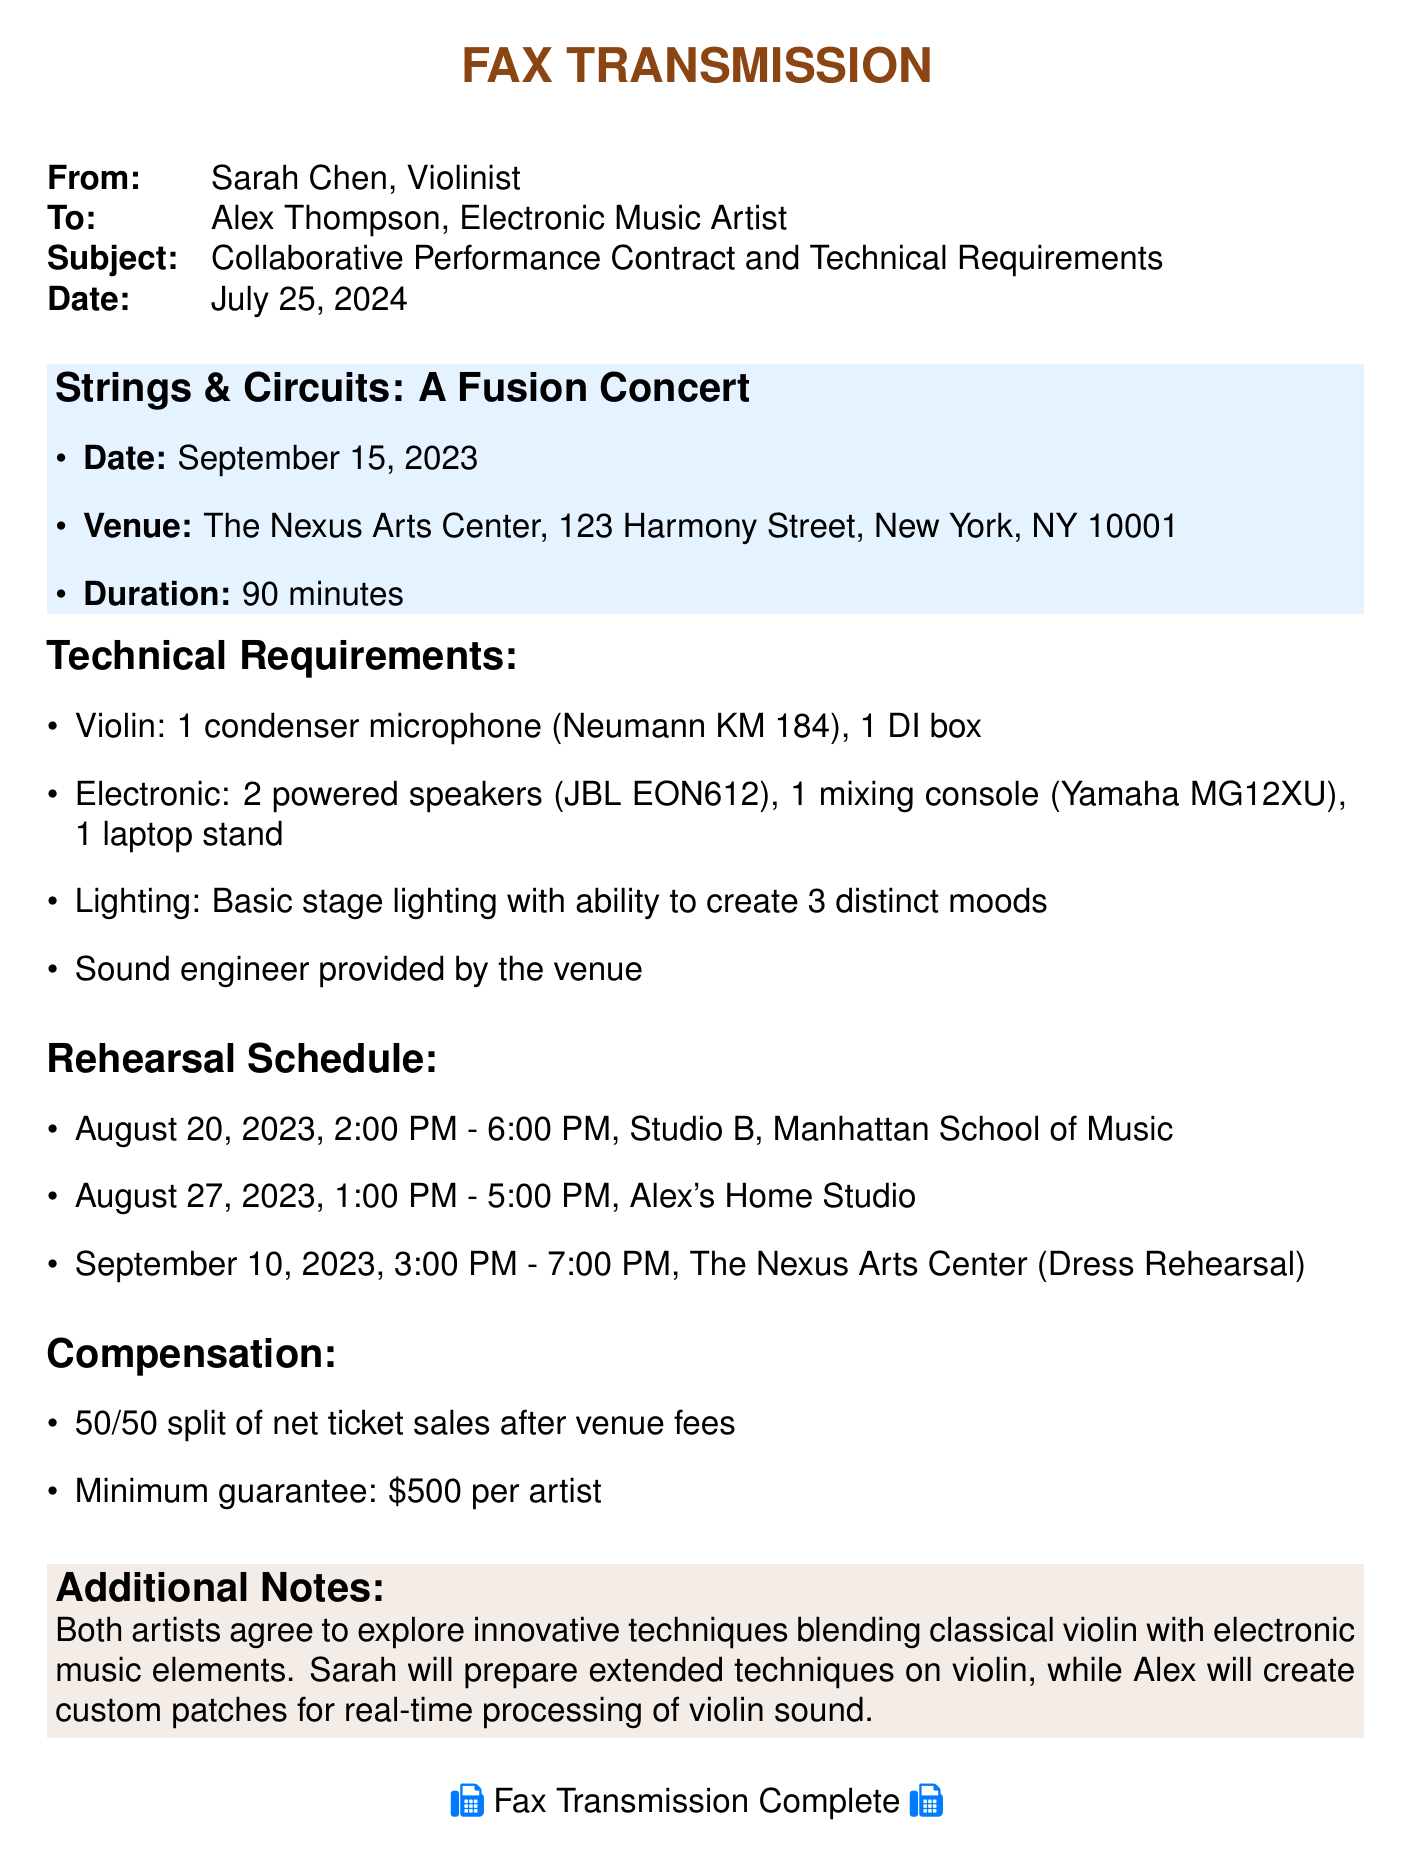what is the date of the performance? The document specifies the performance date as September 15, 2023.
Answer: September 15, 2023 who is the electronic music artist involved? The document indicates that Alex Thompson is the electronic music artist.
Answer: Alex Thompson what is the venue of the concert? The venue listed in the document is The Nexus Arts Center.
Answer: The Nexus Arts Center how many rehearsal sessions are scheduled? The document states there are three scheduled rehearsal sessions.
Answer: Three what is the compensation split between the artists? The document mentions a 50/50 split of net ticket sales after venue fees.
Answer: 50/50 split when is the dress rehearsal scheduled? The document specifies the dress rehearsal date as September 10, 2023.
Answer: September 10, 2023 what type of microphone is required for the violin? The document lists 1 condenser microphone (Neumann KM 184) as required.
Answer: 1 condenser microphone (Neumann KM 184) how long is the concert expected to last? The document mentions that the concert's duration is 90 minutes.
Answer: 90 minutes what is Alex's role in the collaboration? The document states that Alex will create custom patches for real-time processing of violin sound.
Answer: Create custom patches for real-time processing of violin sound 